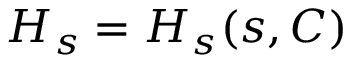<formula> <loc_0><loc_0><loc_500><loc_500>H _ { s } = H _ { s } ( s , C )</formula> 